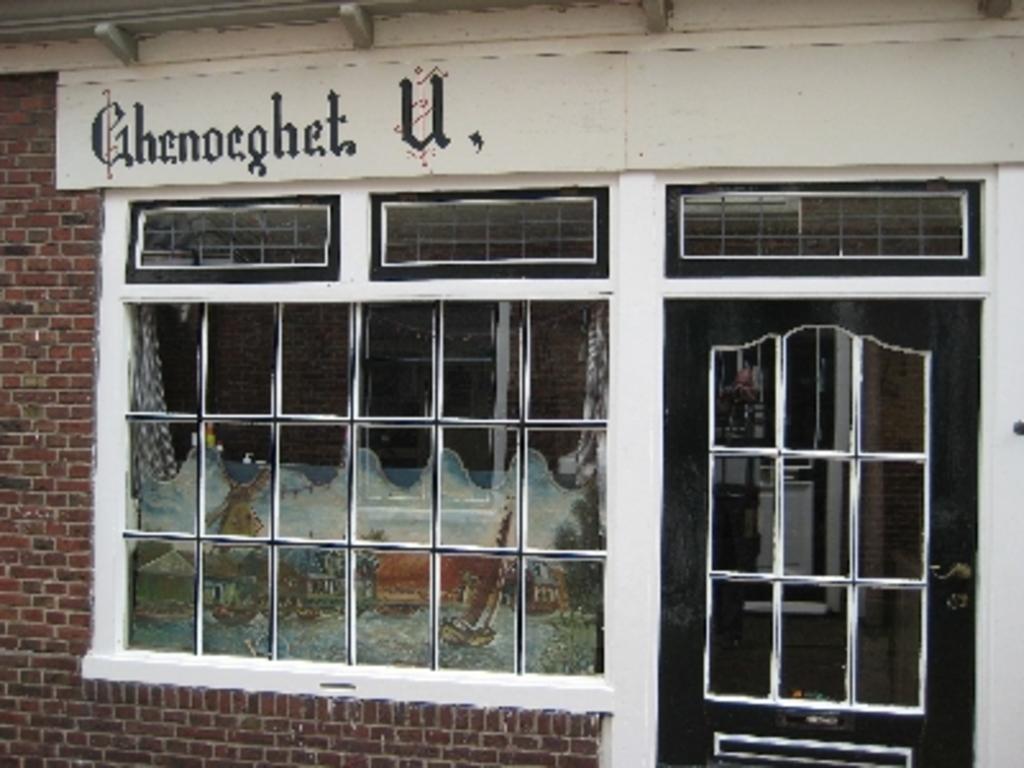What is the store name?
Ensure brevity in your answer.  Ghenoeghet u. 